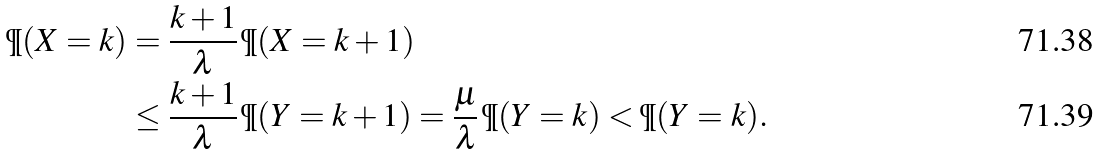Convert formula to latex. <formula><loc_0><loc_0><loc_500><loc_500>\P ( X = k ) & = \frac { k + 1 } { \lambda } \, \P ( X = k + 1 ) \\ & \leq \frac { k + 1 } { \lambda } \, \P ( Y = k + 1 ) = \frac { \mu } { \lambda } \, \P ( Y = k ) < \P ( Y = k ) .</formula> 